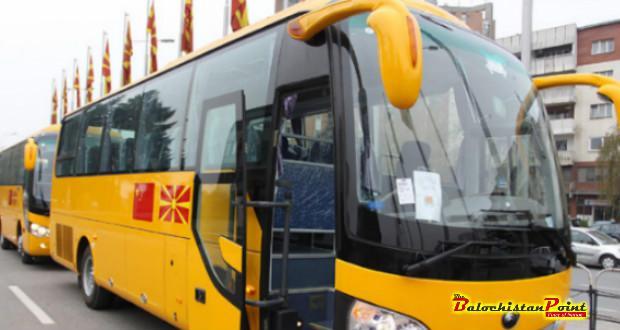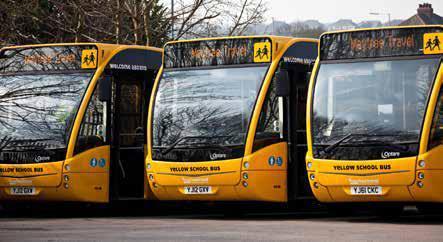The first image is the image on the left, the second image is the image on the right. Evaluate the accuracy of this statement regarding the images: "Yellow school buses are lined up side by side and facing forward in one of the images.". Is it true? Answer yes or no. Yes. The first image is the image on the left, the second image is the image on the right. Assess this claim about the two images: "At least 3 school buses are parked side by side in one of the pictures.". Correct or not? Answer yes or no. Yes. 